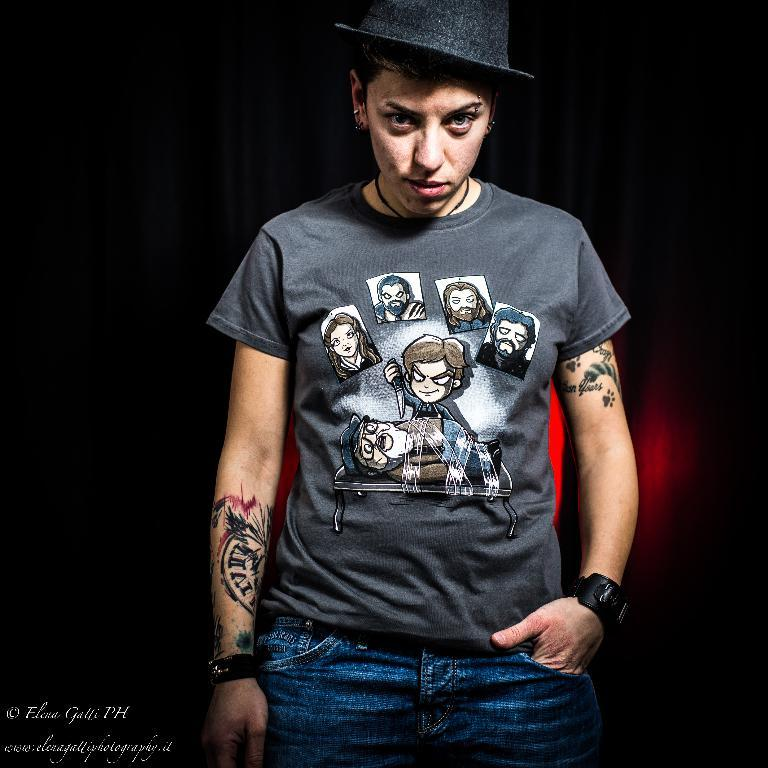Who or what is the main subject in the image? There is a person in the image. What is the person wearing on their head? The person is wearing a black color hat. Where is the person located in the image? The person is standing in the middle of the image. What colors can be seen in the background of the image? The background of the image includes black and red colors. What type of flesh can be seen on the person's face in the image? There is no flesh visible on the person's face in the image, as the person is wearing a hat that covers their face. What kind of voice can be heard coming from the person in the image? There is no sound or voice present in the image, as it is a still photograph. 